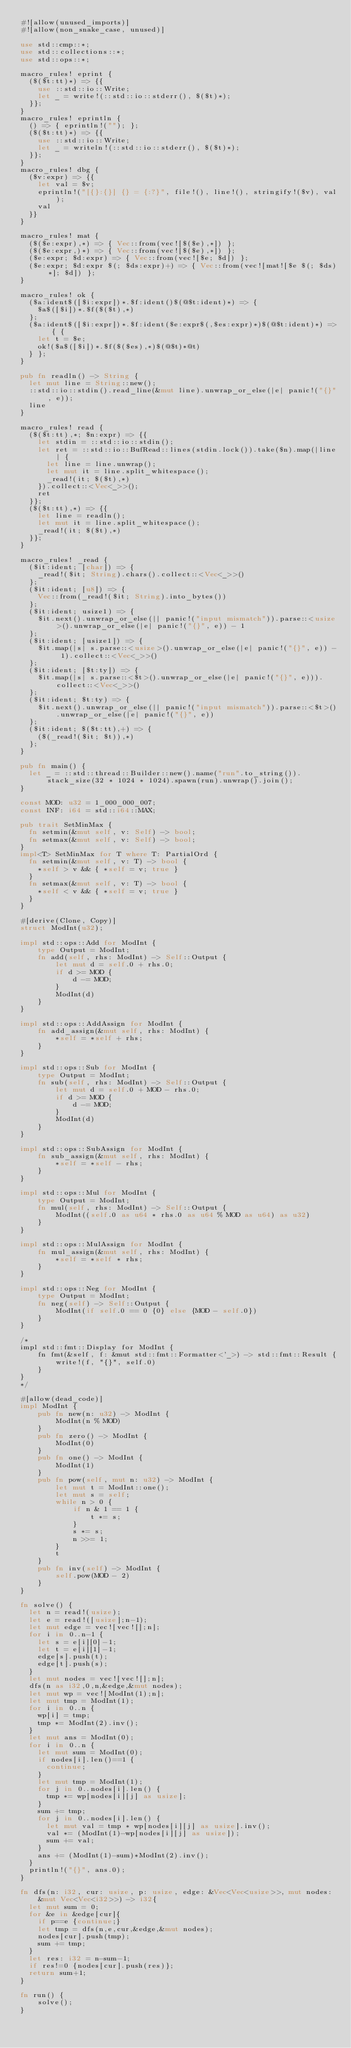Convert code to text. <code><loc_0><loc_0><loc_500><loc_500><_Rust_>#![allow(unused_imports)]
#![allow(non_snake_case, unused)]

use std::cmp::*;
use std::collections::*;
use std::ops::*;

macro_rules! eprint {
	($($t:tt)*) => {{
		use ::std::io::Write;
		let _ = write!(::std::io::stderr(), $($t)*);
	}};
}
macro_rules! eprintln {
	() => { eprintln!(""); };
	($($t:tt)*) => {{
		use ::std::io::Write;
		let _ = writeln!(::std::io::stderr(), $($t)*);
	}};
}
macro_rules! dbg {
	($v:expr) => {{
		let val = $v;
		eprintln!("[{}:{}] {} = {:?}", file!(), line!(), stringify!($v), val);
		val
	}}
}

macro_rules! mat {
	($($e:expr),*) => { Vec::from(vec![$($e),*]) };
	($($e:expr,)*) => { Vec::from(vec![$($e),*]) };
	($e:expr; $d:expr) => { Vec::from(vec![$e; $d]) };
	($e:expr; $d:expr $(; $ds:expr)+) => { Vec::from(vec![mat![$e $(; $ds)*]; $d]) };
}

macro_rules! ok {
	($a:ident$([$i:expr])*.$f:ident()$(@$t:ident)*) => {
		$a$([$i])*.$f($($t),*)
	};
	($a:ident$([$i:expr])*.$f:ident($e:expr$(,$es:expr)*)$(@$t:ident)*) => { {
		let t = $e;
		ok!($a$([$i])*.$f($($es),*)$(@$t)*@t)
	} };
}

pub fn readln() -> String {
	let mut line = String::new();
	::std::io::stdin().read_line(&mut line).unwrap_or_else(|e| panic!("{}", e));
	line
}

macro_rules! read {
	($($t:tt),*; $n:expr) => {{
		let stdin = ::std::io::stdin();
		let ret = ::std::io::BufRead::lines(stdin.lock()).take($n).map(|line| {
			let line = line.unwrap();
			let mut it = line.split_whitespace();
			_read!(it; $($t),*)
		}).collect::<Vec<_>>();
		ret
	}};
	($($t:tt),*) => {{
		let line = readln();
		let mut it = line.split_whitespace();
		_read!(it; $($t),*)
	}};
}

macro_rules! _read {
	($it:ident; [char]) => {
		_read!($it; String).chars().collect::<Vec<_>>()
	};
	($it:ident; [u8]) => {
		Vec::from(_read!($it; String).into_bytes())
	};
	($it:ident; usize1) => {
		$it.next().unwrap_or_else(|| panic!("input mismatch")).parse::<usize>().unwrap_or_else(|e| panic!("{}", e)) - 1
	};
	($it:ident; [usize1]) => {
		$it.map(|s| s.parse::<usize>().unwrap_or_else(|e| panic!("{}", e)) - 1).collect::<Vec<_>>()
	};
	($it:ident; [$t:ty]) => {
		$it.map(|s| s.parse::<$t>().unwrap_or_else(|e| panic!("{}", e))).collect::<Vec<_>>()
	};
	($it:ident; $t:ty) => {
		$it.next().unwrap_or_else(|| panic!("input mismatch")).parse::<$t>().unwrap_or_else(|e| panic!("{}", e))
	};
	($it:ident; $($t:tt),+) => {
		($(_read!($it; $t)),*)
	};
}

pub fn main() {
	let _ = ::std::thread::Builder::new().name("run".to_string()).stack_size(32 * 1024 * 1024).spawn(run).unwrap().join();
}

const MOD: u32 = 1_000_000_007;
const INF: i64 = std::i64::MAX;

pub trait SetMinMax {
	fn setmin(&mut self, v: Self) -> bool;
	fn setmax(&mut self, v: Self) -> bool;
}
impl<T> SetMinMax for T where T: PartialOrd {
	fn setmin(&mut self, v: T) -> bool {
		*self > v && { *self = v; true }
	}
	fn setmax(&mut self, v: T) -> bool {
		*self < v && { *self = v; true }
	}
}

#[derive(Clone, Copy)]
struct ModInt(u32);
 
impl std::ops::Add for ModInt {
    type Output = ModInt;
    fn add(self, rhs: ModInt) -> Self::Output {
        let mut d = self.0 + rhs.0;
        if d >= MOD {
            d -= MOD;
        }
        ModInt(d)
    }
}
 
impl std::ops::AddAssign for ModInt {
    fn add_assign(&mut self, rhs: ModInt) {
        *self = *self + rhs;
    }
}
 
impl std::ops::Sub for ModInt {
    type Output = ModInt;
    fn sub(self, rhs: ModInt) -> Self::Output {
        let mut d = self.0 + MOD - rhs.0;
        if d >= MOD {
            d -= MOD;
        }
        ModInt(d)
    }
}
 
impl std::ops::SubAssign for ModInt {
    fn sub_assign(&mut self, rhs: ModInt) {
        *self = *self - rhs;
    }
}
 
impl std::ops::Mul for ModInt {
    type Output = ModInt;
    fn mul(self, rhs: ModInt) -> Self::Output {
        ModInt((self.0 as u64 * rhs.0 as u64 % MOD as u64) as u32)
    }
}
 
impl std::ops::MulAssign for ModInt {
    fn mul_assign(&mut self, rhs: ModInt) {
        *self = *self * rhs;
    }
}
 
impl std::ops::Neg for ModInt {
    type Output = ModInt;
    fn neg(self) -> Self::Output {
        ModInt(if self.0 == 0 {0} else {MOD - self.0})
    }
}
 
/* 
impl std::fmt::Display for ModInt {
    fn fmt(&self, f: &mut std::fmt::Formatter<'_>) -> std::fmt::Result {
        write!(f, "{}", self.0)
    }
}
*/
 
#[allow(dead_code)]
impl ModInt {
    pub fn new(n: u32) -> ModInt {
        ModInt(n % MOD)
    }
    pub fn zero() -> ModInt {
        ModInt(0)
    }
    pub fn one() -> ModInt {
        ModInt(1)
    }
    pub fn pow(self, mut n: u32) -> ModInt {
        let mut t = ModInt::one();
        let mut s = self;
        while n > 0 {
            if n & 1 == 1 {
                t *= s;
            }
            s *= s;
            n >>= 1;
        }
        t
    }
    pub fn inv(self) -> ModInt {
        self.pow(MOD - 2)
    }
}

fn solve() {
	let n = read!(usize);
	let e = read!([usize];n-1);
	let mut edge = vec![vec![];n];
	for i in 0..n-1 {
		let s = e[i][0]-1;
		let t = e[i][1]-1;
		edge[s].push(t);
		edge[t].push(s);
	}	
	let mut nodes = vec![vec![];n];
	dfs(n as i32,0,n,&edge,&mut nodes);
	let mut wp = vec![ModInt(1);n];
	let mut tmp = ModInt(1);
	for i in 0..n {
		wp[i] = tmp;
		tmp *= ModInt(2).inv();
	}
	let mut ans = ModInt(0);
	for i in 0..n {
		let mut sum = ModInt(0);
		if nodes[i].len()==1 {
			continue;
		}
		let mut tmp = ModInt(1);
		for j in 0..nodes[i].len() {
			tmp *= wp[nodes[i][j] as usize];
		}
		sum += tmp;
		for j in 0..nodes[i].len() {
			let mut val = tmp * wp[nodes[i][j] as usize].inv();
			val *= (ModInt(1)-wp[nodes[i][j] as usize]);
			sum += val;
		}
		ans += (ModInt(1)-sum)*ModInt(2).inv();
	}
	println!("{}", ans.0);
}

fn dfs(n: i32, cur: usize, p: usize, edge: &Vec<Vec<usize>>, mut nodes: &mut Vec<Vec<i32>>) -> i32{
	let mut sum = 0;
	for &e in &edge[cur]{
		if p==e {continue;}
		let tmp = dfs(n,e,cur,&edge,&mut nodes);
		nodes[cur].push(tmp);
		sum += tmp;
	}
	let res: i32 = n-sum-1;
	if res!=0 {nodes[cur].push(res)};
	return sum+1;
}

fn run() {
    solve();
}</code> 